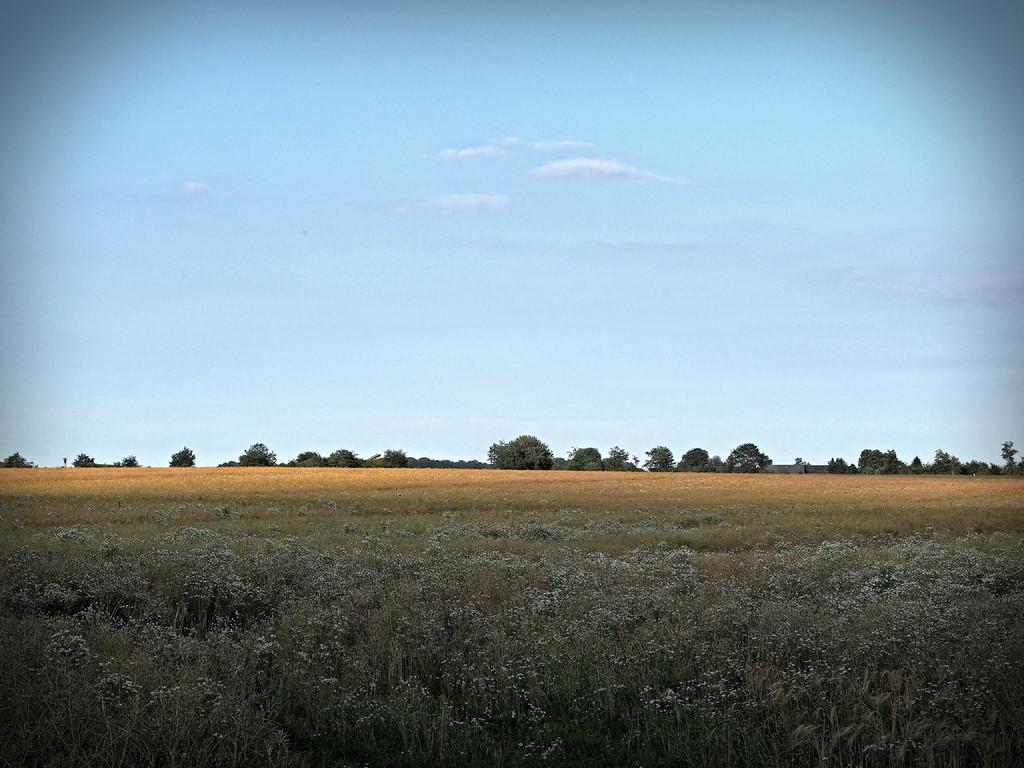What type of landscape is at the bottom of the image? There is a field at the bottom of the image. What can be seen in the middle of the image? There are trees in the middle of the image. What is visible in the background of the image? The sky is visible in the background of the image. Where is the cactus located in the image? There is no cactus present in the image. What letter can be seen on the trees in the image? There are no letters visible on the trees in the image. 